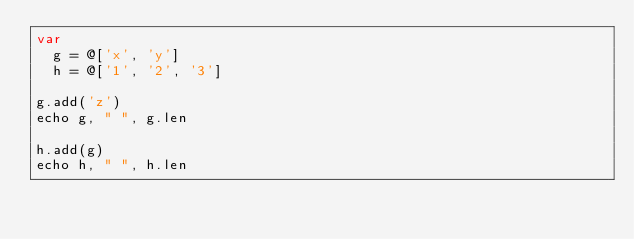<code> <loc_0><loc_0><loc_500><loc_500><_Nim_>var
  g = @['x', 'y']
  h = @['1', '2', '3']

g.add('z')
echo g, " ", g.len

h.add(g)
echo h, " ", h.len

</code> 